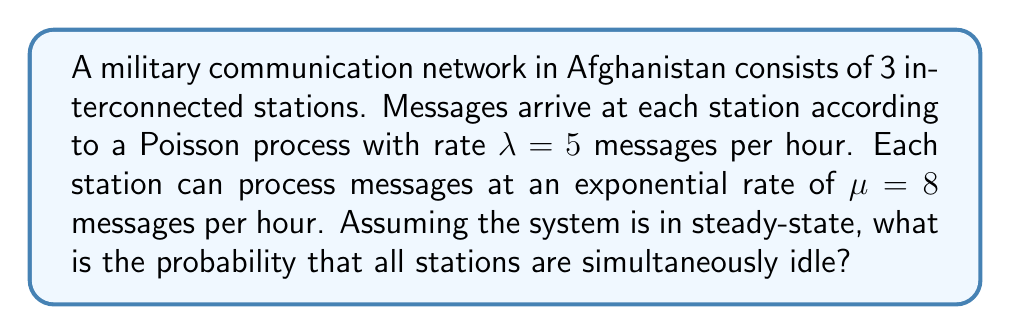What is the answer to this math problem? To solve this problem, we'll use concepts from queueing theory and stochastic networks:

1. Each station can be modeled as an M/M/1 queue, where:
   - M: Arrivals follow a Poisson process
   - M: Service times are exponentially distributed
   - 1: Single server at each station

2. For an M/M/1 queue, the utilization factor $\rho$ is given by:
   $$\rho = \frac{\lambda}{\mu}$$

3. Calculate $\rho$ for each station:
   $$\rho = \frac{5}{8} = 0.625$$

4. The probability of an M/M/1 queue being idle (empty) is:
   $$P(\text{idle}) = 1 - \rho = 1 - 0.625 = 0.375$$

5. Since we have 3 independent stations, the probability of all stations being simultaneously idle is the product of their individual idle probabilities:
   $$P(\text{all idle}) = (0.375)^3 = 0.052734375$$

6. Round to 4 decimal places:
   $$P(\text{all idle}) \approx 0.0527$$
Answer: 0.0527 